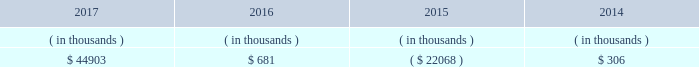All debt and common and preferred stock issuances by entergy texas require prior regulatory approval .
Debt issuances are also subject to issuance tests set forth in its bond indenture and other agreements .
Entergy texas has sufficient capacity under these tests to meet its foreseeable capital needs .
Entergy texas 2019s receivables from or ( payables to ) the money pool were as follows as of december 31 for each of the following years. .
See note 4 to the financial statements for a description of the money pool .
Entergy texas has a credit facility in the amount of $ 150 million scheduled to expire in august 2022 .
The credit facility allows entergy texas to issue letters of credit against $ 30 million of the borrowing capacity of the facility .
As of december 31 , 2017 , there were no cash borrowings and $ 25.6 million of letters of credit outstanding under the credit facility .
In addition , entergy texas is a party to an uncommitted letter of credit facility as a means to post collateral to support its obligations to miso .
As of december 31 , 2017 , a $ 22.8 million letter of credit was outstanding under entergy texas 2019s letter of credit facility .
See note 4 to the financial statements for additional discussion of the credit facilities .
Entergy texas obtained authorizations from the ferc through october 2019 for short-term borrowings , not to exceed an aggregate amount of $ 200 million at any time outstanding , and long-term borrowings and security issuances .
See note 4 to the financial statements for further discussion of entergy texas 2019s short-term borrowing limits .
Entergy texas , inc .
And subsidiaries management 2019s financial discussion and analysis state and local rate regulation and fuel-cost recovery the rates that entergy texas charges for its services significantly influence its financial position , results of operations , and liquidity .
Entergy texas is regulated and the rates charged to its customers are determined in regulatory proceedings .
The puct , a governmental agency , is primarily responsible for approval of the rates charged to customers .
Filings with the puct 2011 rate case in november 2011 , entergy texas filed a rate case requesting a $ 112 million base rate increase reflecting a 10.6% ( 10.6 % ) return on common equity based on an adjusted june 2011 test year . a0 a0the rate case also proposed a purchased power recovery rider . a0 a0on january 12 , 2012 , the puct voted not to address the purchased power recovery rider in the rate case , but the puct voted to set a baseline in the rate case proceeding that would be applicable if a purchased power capacity rider is approved in a separate proceeding . a0 a0in april 2012 the puct staff filed direct testimony recommending a base rate increase of $ 66 million and a 9.6% ( 9.6 % ) return on common equity . a0 a0the puct staff , however , subsequently filed a statement of position in the proceeding indicating that it was still evaluating the position it would ultimately take in the case regarding entergy texas 2019s recovery of purchased power capacity costs and entergy texas 2019s proposal to defer its miso transition expenses . a0 a0in april 2012 , entergy texas filed rebuttal testimony indicating a revised request for a $ 105 million base rate increase . a0 a0a hearing was held in late-april through early-may 2012 .
In september 2012 the puct issued an order approving a $ 28 million rate increase , effective july 2012 . a0 a0the order included a finding that 201ca return on common equity ( roe ) of 9.80 percent will allow [entergy texas] a reasonable opportunity to earn a reasonable return on invested capital . 201d a0 a0the order also provided for increases in depreciation rates and the annual storm reserve accrual . a0 a0the order also reduced entergy texas 2019s proposed purchased power capacity costs , stating that they are not known and measurable ; reduced entergy texas 2019s regulatory assets associated with hurricane rita ; excluded from rate recovery capitalized financially-based incentive compensation ; included $ 1.6 million of miso transition expense in base rates ; and reduced entergy 2019s texas 2019s fuel reconciliation recovery by $ 4 .
As of december 31 , 2017 what was the percent of the utilization of the allowed letter of credit limit on the entergy texas? 
Computations: (25.6 / 30)
Answer: 0.85333. 